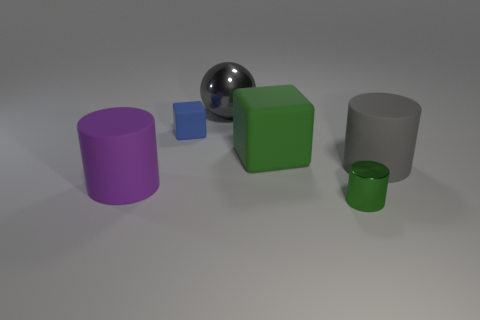How many other objects are there of the same shape as the small blue rubber object?
Offer a terse response. 1. What number of large things are behind the purple object?
Ensure brevity in your answer.  3. Are there fewer gray rubber cylinders behind the large metal thing than gray objects behind the tiny blue rubber object?
Your answer should be very brief. Yes. The green object that is behind the matte cylinder on the left side of the green thing that is in front of the purple rubber cylinder is what shape?
Give a very brief answer. Cube. The thing that is left of the large gray ball and in front of the tiny blue object has what shape?
Ensure brevity in your answer.  Cylinder. Is there a tiny green cylinder that has the same material as the blue cube?
Make the answer very short. No. The matte cube that is the same color as the small metal object is what size?
Offer a terse response. Large. There is a metallic object that is on the left side of the tiny metallic cylinder; what is its color?
Offer a very short reply. Gray. Does the purple thing have the same shape as the tiny object behind the big purple object?
Provide a short and direct response. No. Is there a matte object that has the same color as the large block?
Offer a terse response. No. 